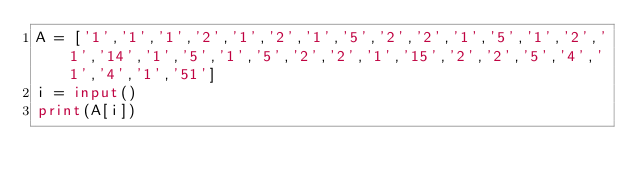<code> <loc_0><loc_0><loc_500><loc_500><_Python_>A = ['1','1','1','2','1','2','1','5','2','2','1','5','1','2','1','14','1','5','1','5','2','2','1','15','2','2','5','4','1','4','1','51']
i = input()
print(A[i])</code> 